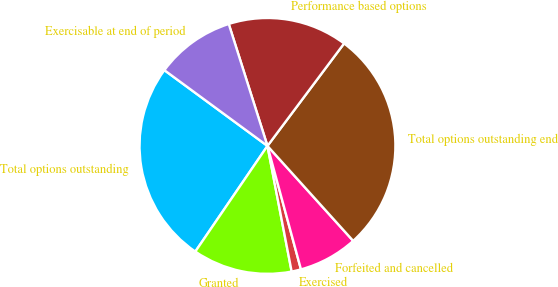<chart> <loc_0><loc_0><loc_500><loc_500><pie_chart><fcel>Total options outstanding<fcel>Granted<fcel>Exercised<fcel>Forfeited and cancelled<fcel>Total options outstanding end<fcel>Performance based options<fcel>Exercisable at end of period<nl><fcel>25.55%<fcel>12.56%<fcel>1.19%<fcel>7.47%<fcel>28.09%<fcel>15.11%<fcel>10.02%<nl></chart> 